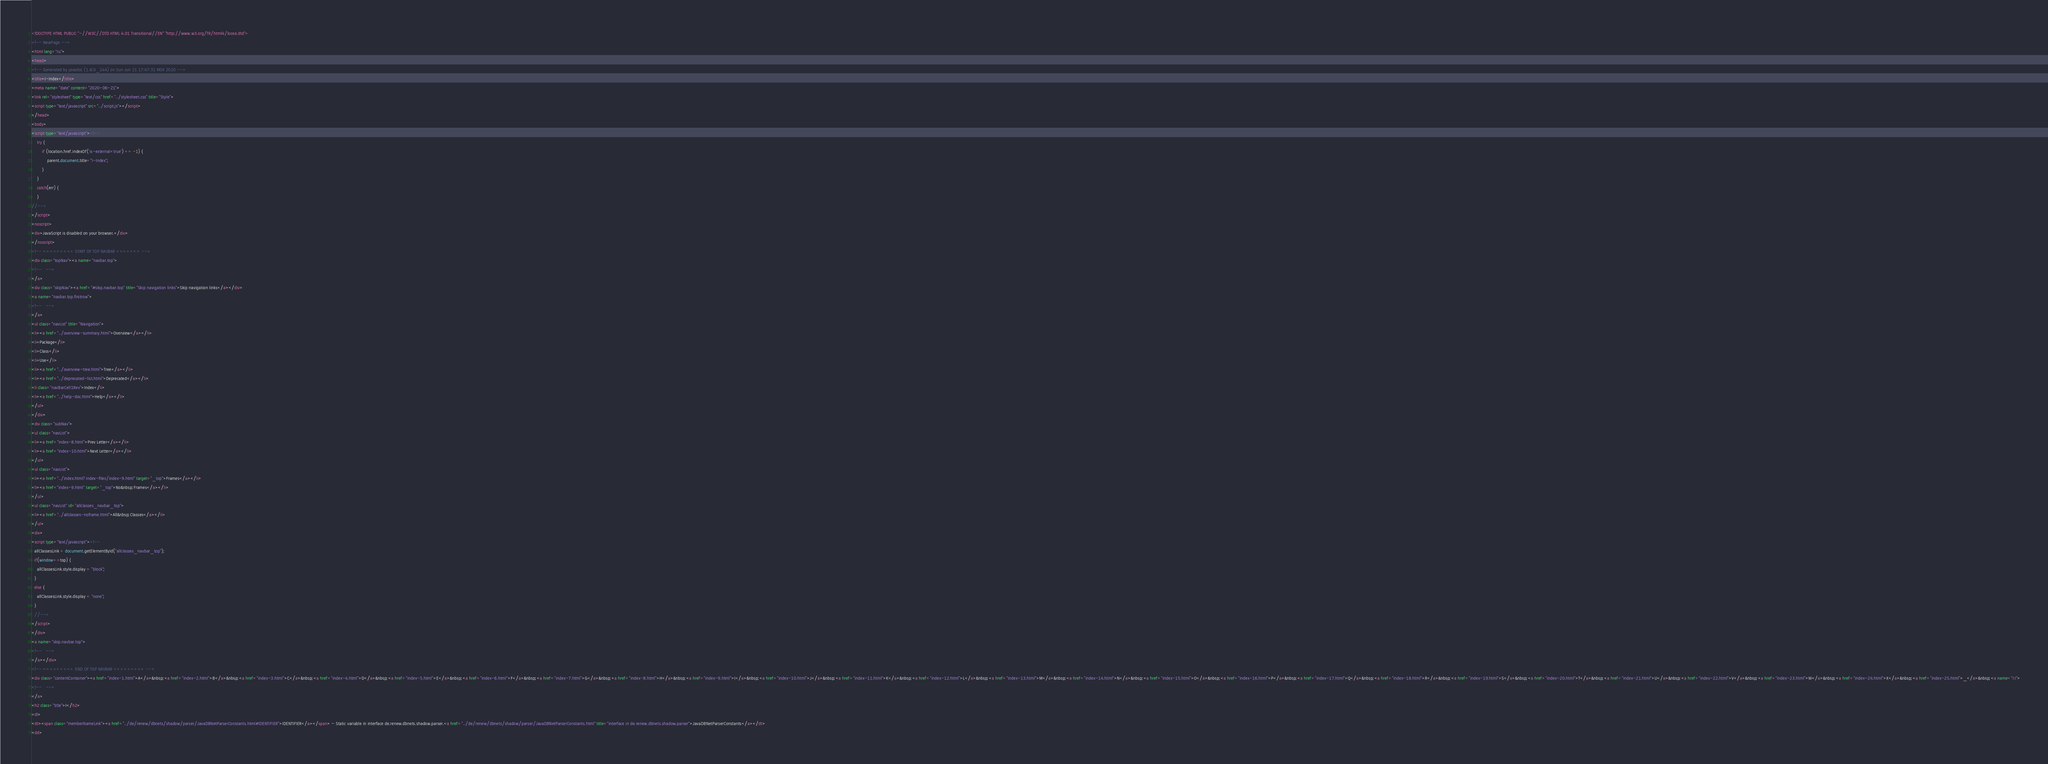Convert code to text. <code><loc_0><loc_0><loc_500><loc_500><_HTML_><!DOCTYPE HTML PUBLIC "-//W3C//DTD HTML 4.01 Transitional//EN" "http://www.w3.org/TR/html4/loose.dtd">
<!-- NewPage -->
<html lang="ru">
<head>
<!-- Generated by javadoc (1.8.0_144) on Sun Jun 21 17:47:31 MSK 2020 -->
<title>I-Index</title>
<meta name="date" content="2020-06-21">
<link rel="stylesheet" type="text/css" href="../stylesheet.css" title="Style">
<script type="text/javascript" src="../script.js"></script>
</head>
<body>
<script type="text/javascript"><!--
    try {
        if (location.href.indexOf('is-external=true') == -1) {
            parent.document.title="I-Index";
        }
    }
    catch(err) {
    }
//-->
</script>
<noscript>
<div>JavaScript is disabled on your browser.</div>
</noscript>
<!-- ========= START OF TOP NAVBAR ======= -->
<div class="topNav"><a name="navbar.top">
<!--   -->
</a>
<div class="skipNav"><a href="#skip.navbar.top" title="Skip navigation links">Skip navigation links</a></div>
<a name="navbar.top.firstrow">
<!--   -->
</a>
<ul class="navList" title="Navigation">
<li><a href="../overview-summary.html">Overview</a></li>
<li>Package</li>
<li>Class</li>
<li>Use</li>
<li><a href="../overview-tree.html">Tree</a></li>
<li><a href="../deprecated-list.html">Deprecated</a></li>
<li class="navBarCell1Rev">Index</li>
<li><a href="../help-doc.html">Help</a></li>
</ul>
</div>
<div class="subNav">
<ul class="navList">
<li><a href="index-8.html">Prev Letter</a></li>
<li><a href="index-10.html">Next Letter</a></li>
</ul>
<ul class="navList">
<li><a href="../index.html?index-files/index-9.html" target="_top">Frames</a></li>
<li><a href="index-9.html" target="_top">No&nbsp;Frames</a></li>
</ul>
<ul class="navList" id="allclasses_navbar_top">
<li><a href="../allclasses-noframe.html">All&nbsp;Classes</a></li>
</ul>
<div>
<script type="text/javascript"><!--
  allClassesLink = document.getElementById("allclasses_navbar_top");
  if(window==top) {
    allClassesLink.style.display = "block";
  }
  else {
    allClassesLink.style.display = "none";
  }
  //-->
</script>
</div>
<a name="skip.navbar.top">
<!--   -->
</a></div>
<!-- ========= END OF TOP NAVBAR ========= -->
<div class="contentContainer"><a href="index-1.html">A</a>&nbsp;<a href="index-2.html">B</a>&nbsp;<a href="index-3.html">C</a>&nbsp;<a href="index-4.html">D</a>&nbsp;<a href="index-5.html">E</a>&nbsp;<a href="index-6.html">F</a>&nbsp;<a href="index-7.html">G</a>&nbsp;<a href="index-8.html">H</a>&nbsp;<a href="index-9.html">I</a>&nbsp;<a href="index-10.html">J</a>&nbsp;<a href="index-11.html">K</a>&nbsp;<a href="index-12.html">L</a>&nbsp;<a href="index-13.html">M</a>&nbsp;<a href="index-14.html">N</a>&nbsp;<a href="index-15.html">O</a>&nbsp;<a href="index-16.html">P</a>&nbsp;<a href="index-17.html">Q</a>&nbsp;<a href="index-18.html">R</a>&nbsp;<a href="index-19.html">S</a>&nbsp;<a href="index-20.html">T</a>&nbsp;<a href="index-21.html">U</a>&nbsp;<a href="index-22.html">V</a>&nbsp;<a href="index-23.html">W</a>&nbsp;<a href="index-24.html">X</a>&nbsp;<a href="index-25.html">_</a>&nbsp;<a name="I:I">
<!--   -->
</a>
<h2 class="title">I</h2>
<dl>
<dt><span class="memberNameLink"><a href="../de/renew/dbnets/shadow/parser/JavaDBNetParserConstants.html#IDENTIFIER">IDENTIFIER</a></span> - Static variable in interface de.renew.dbnets.shadow.parser.<a href="../de/renew/dbnets/shadow/parser/JavaDBNetParserConstants.html" title="interface in de.renew.dbnets.shadow.parser">JavaDBNetParserConstants</a></dt>
<dd></code> 